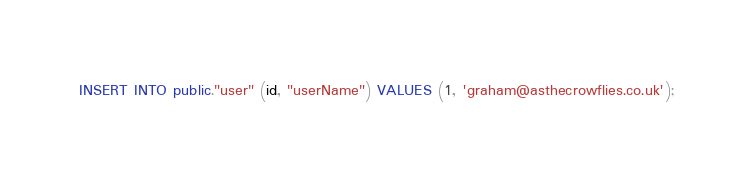<code> <loc_0><loc_0><loc_500><loc_500><_SQL_>INSERT INTO public."user" (id, "userName") VALUES (1, 'graham@asthecrowflies.co.uk');</code> 